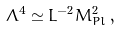Convert formula to latex. <formula><loc_0><loc_0><loc_500><loc_500>\Lambda ^ { 4 } \simeq L ^ { - 2 } M _ { P l } ^ { 2 } \, ,</formula> 